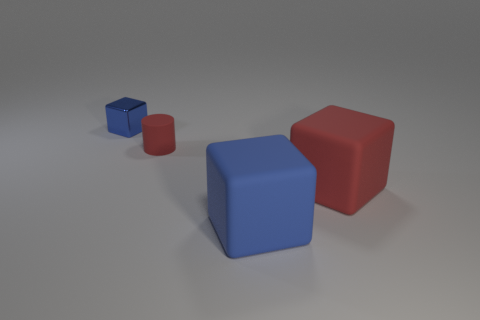Are there any large rubber cubes that have the same color as the tiny rubber thing?
Provide a succinct answer. Yes. Do the large blue block and the blue thing that is behind the big red cube have the same material?
Keep it short and to the point. No. There is a object that is behind the big blue matte block and in front of the small rubber cylinder; what material is it?
Make the answer very short. Rubber. What color is the object that is to the right of the blue cube that is to the right of the tiny matte object?
Provide a succinct answer. Red. What is the blue block right of the small shiny object made of?
Your response must be concise. Rubber. Are there fewer big things than things?
Your answer should be very brief. Yes. Is the shape of the tiny red thing the same as the object that is behind the small rubber cylinder?
Your answer should be very brief. No. The object that is both in front of the metallic cube and behind the big red rubber block has what shape?
Provide a succinct answer. Cylinder. Are there an equal number of large cubes that are in front of the large blue block and small red things in front of the small blue shiny object?
Your response must be concise. No. Does the blue object on the left side of the tiny matte cylinder have the same shape as the tiny red matte thing?
Offer a terse response. No. 